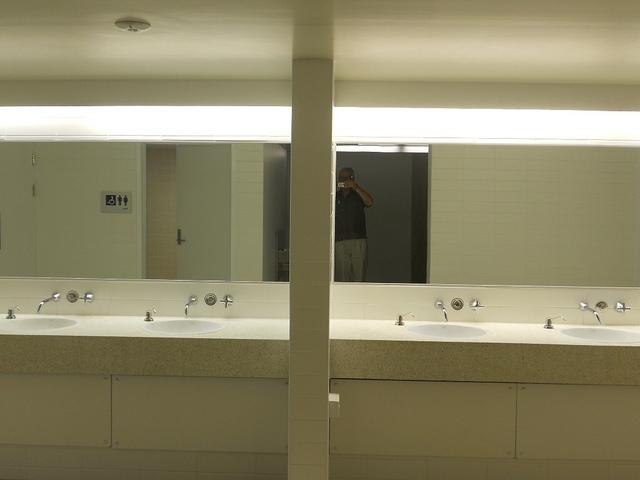What bathroom is it on the right?

Choices:
A) women
B) handicapped
C) transgender woman
D) men men 